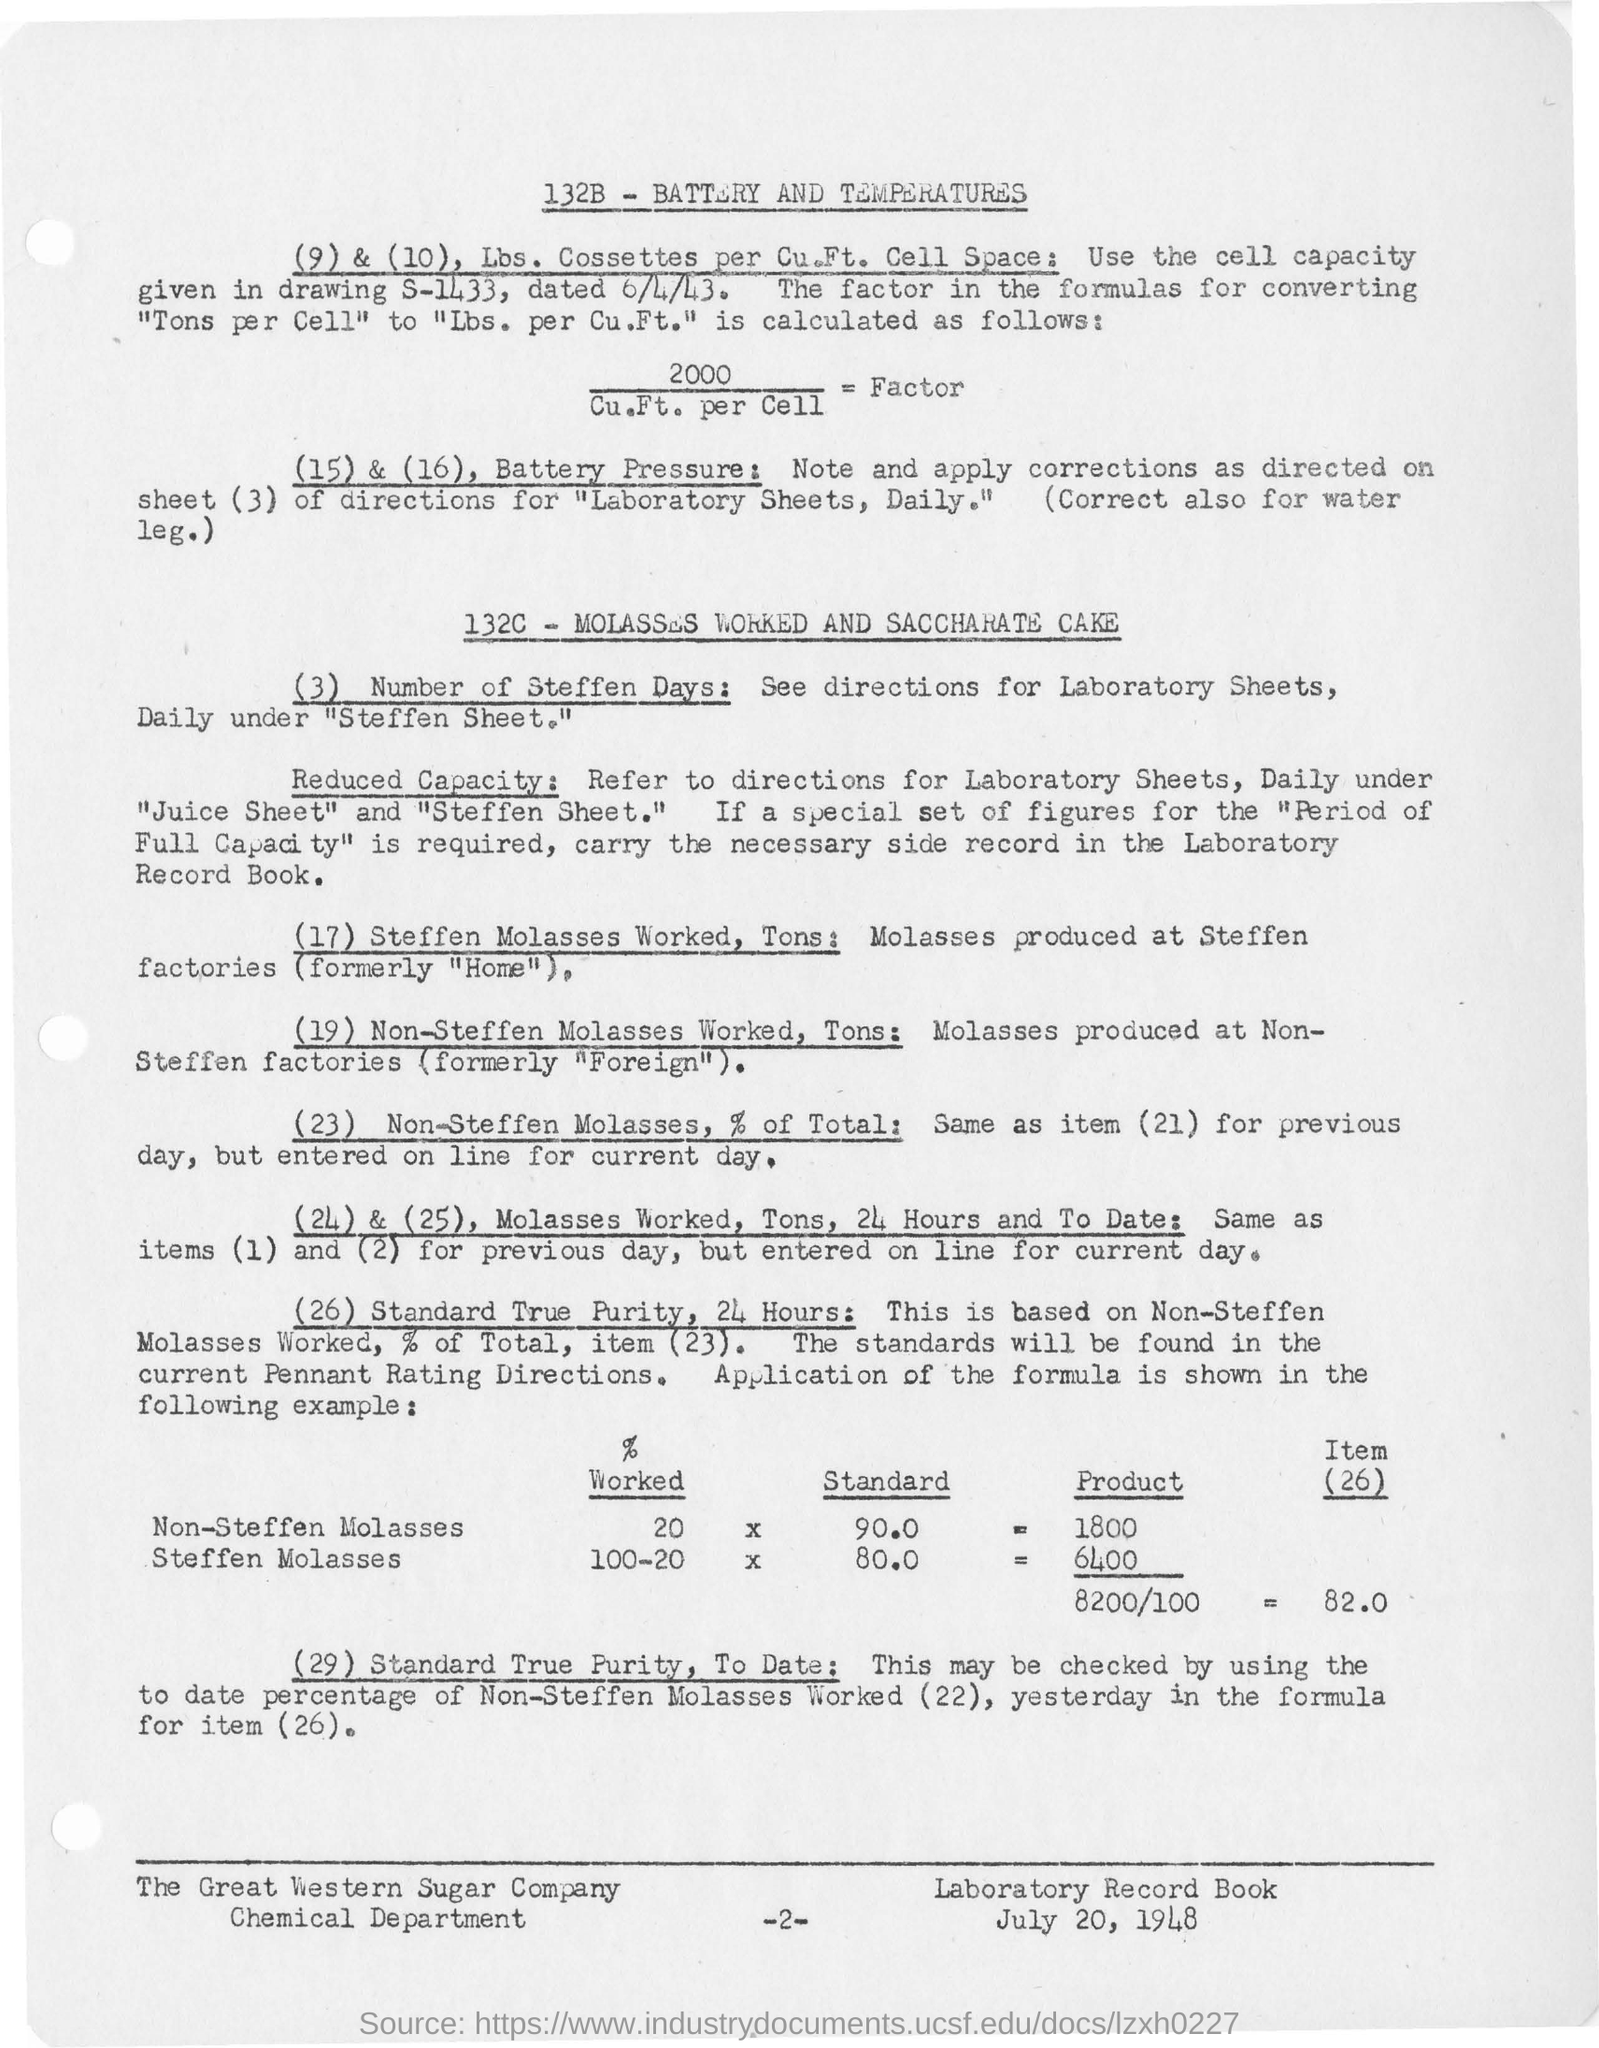Specify some key components in this picture. The drawing number S-1433 shows the capacity of the cell. 